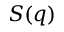Convert formula to latex. <formula><loc_0><loc_0><loc_500><loc_500>S ( q )</formula> 